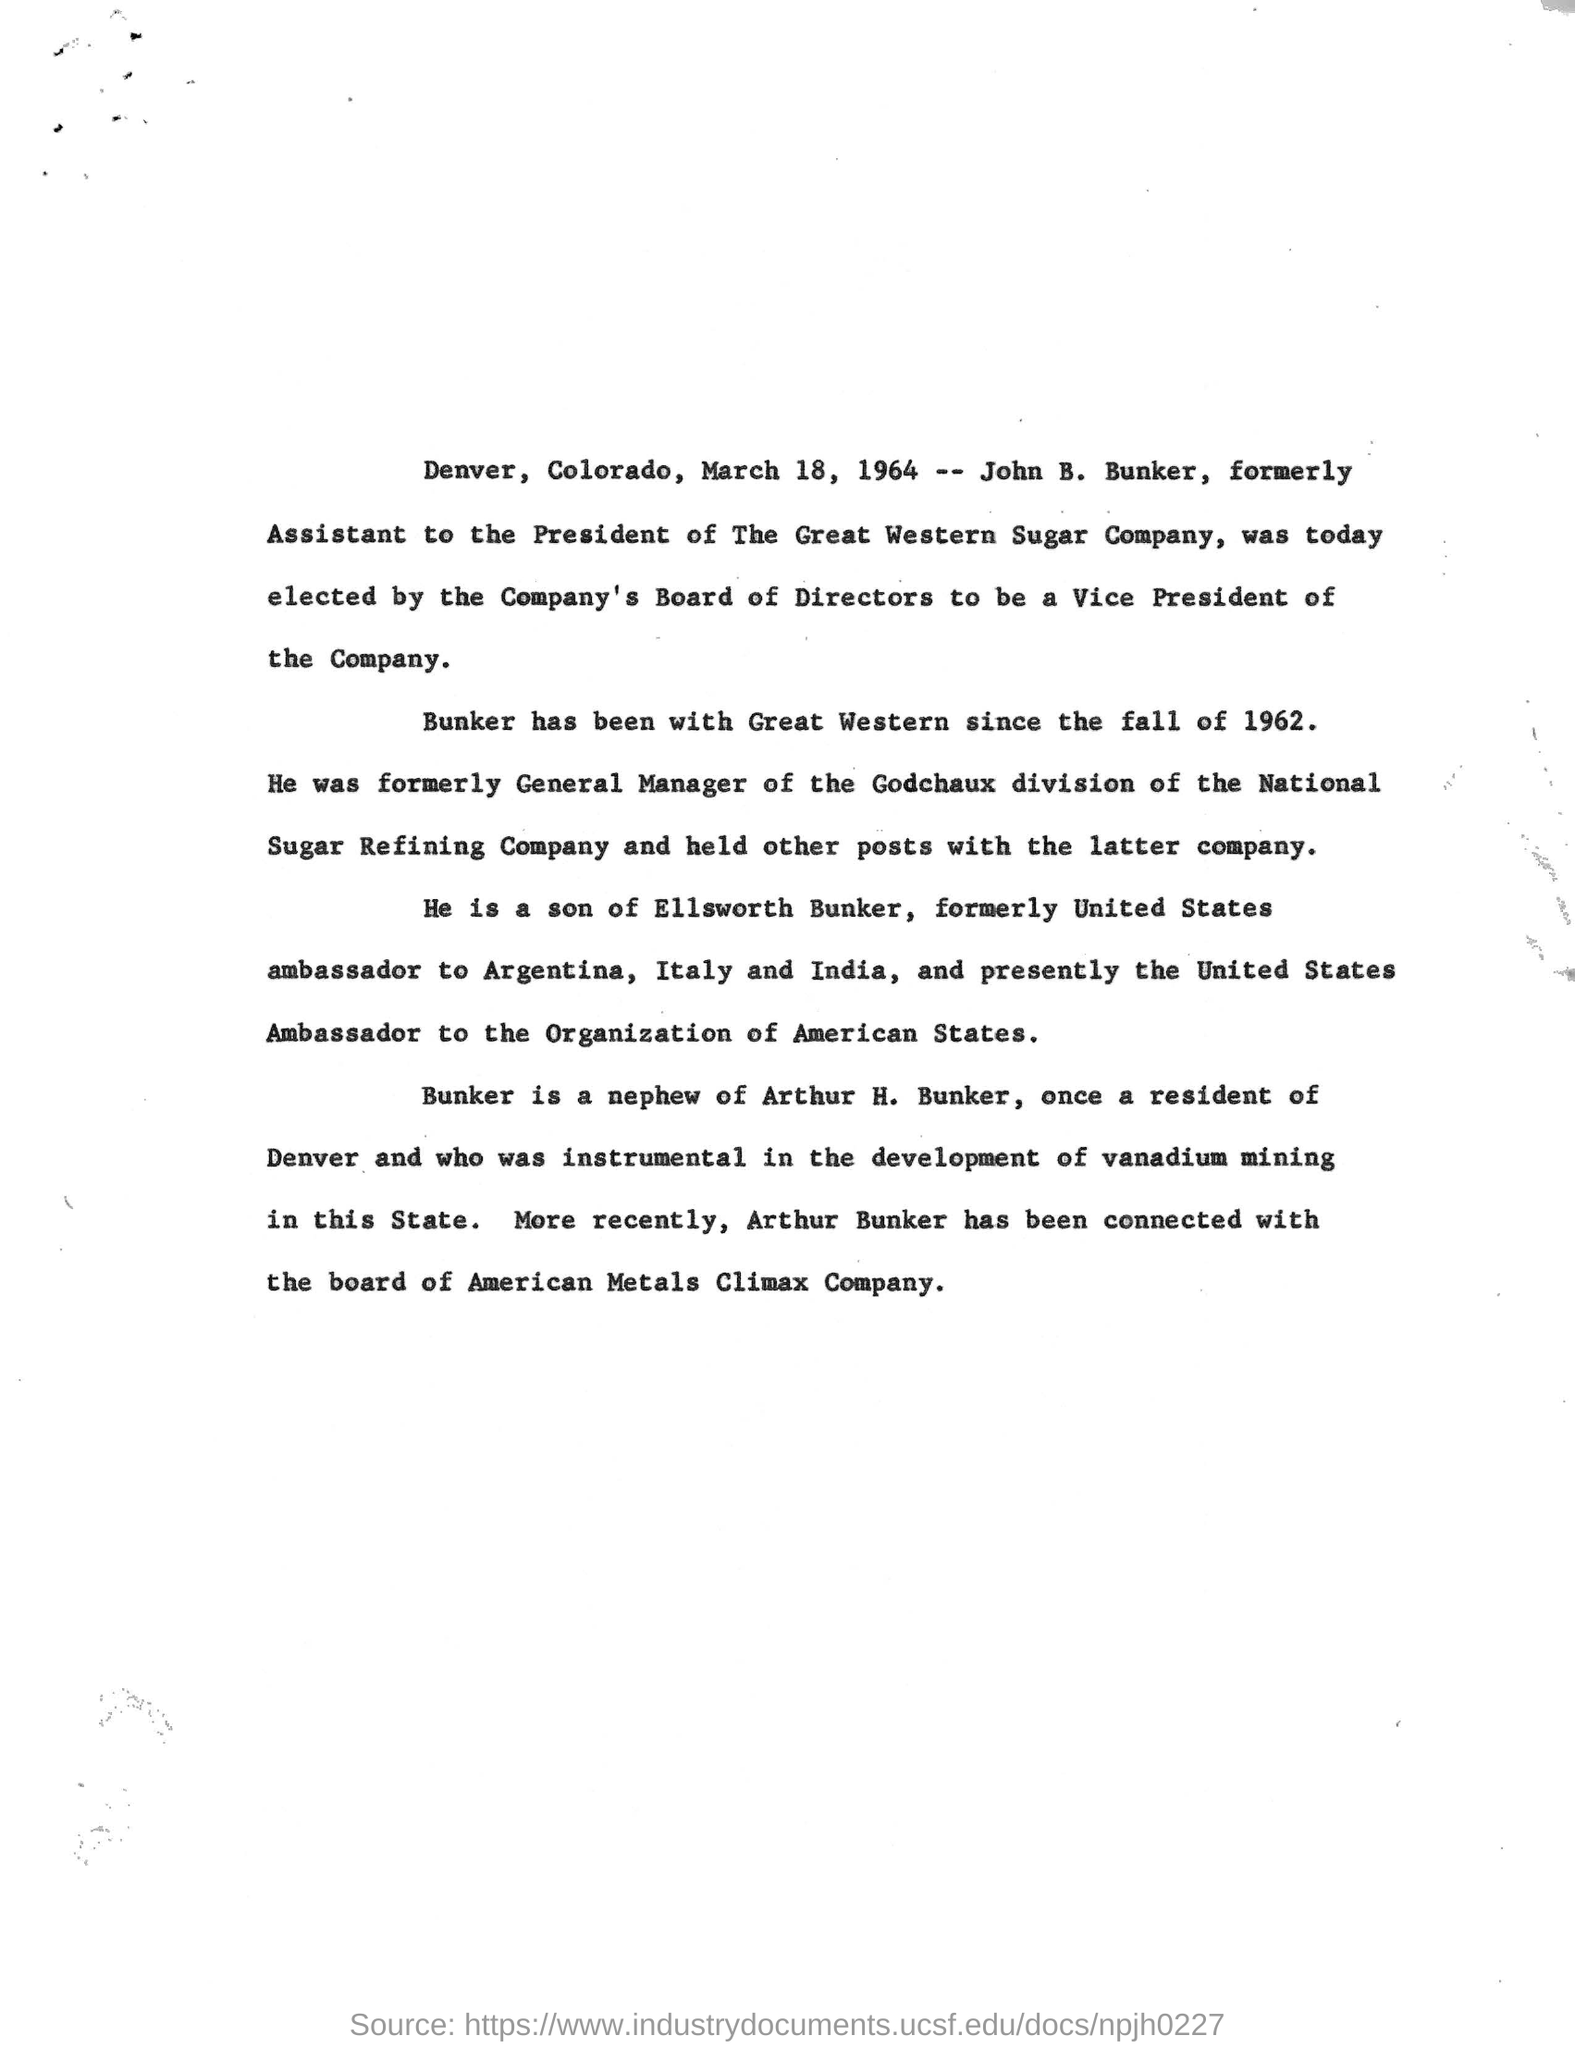Draw attention to some important aspects in this diagram. Arthur H. Bunker's nephew is Bunker. John B. Bunker was elected as the Vice President of The Great Western Sugar Company. On January 6th, 2023, John B. Bunker was designated to be elected as the Vice President of the Great Western Sugar Company. John B. Bunker has been associated with the Great Western Sugar Company since the fall of 1962. 